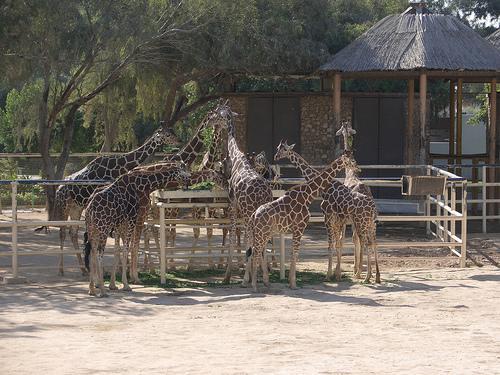How many doors are on the building?
Give a very brief answer. 2. How many giraffes are in the photo?
Give a very brief answer. 6. How many kites are in the sky?
Give a very brief answer. 0. 